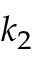Convert formula to latex. <formula><loc_0><loc_0><loc_500><loc_500>k _ { 2 }</formula> 